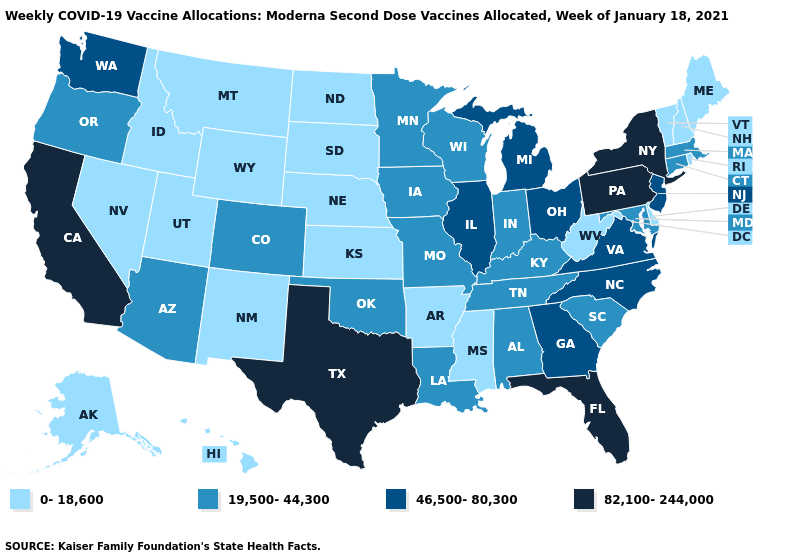What is the highest value in the MidWest ?
Write a very short answer. 46,500-80,300. Among the states that border Indiana , which have the highest value?
Quick response, please. Illinois, Michigan, Ohio. What is the value of Indiana?
Short answer required. 19,500-44,300. Which states have the lowest value in the South?
Give a very brief answer. Arkansas, Delaware, Mississippi, West Virginia. Does Colorado have the lowest value in the West?
Short answer required. No. Among the states that border Massachusetts , which have the lowest value?
Short answer required. New Hampshire, Rhode Island, Vermont. Which states have the lowest value in the USA?
Give a very brief answer. Alaska, Arkansas, Delaware, Hawaii, Idaho, Kansas, Maine, Mississippi, Montana, Nebraska, Nevada, New Hampshire, New Mexico, North Dakota, Rhode Island, South Dakota, Utah, Vermont, West Virginia, Wyoming. What is the lowest value in states that border Delaware?
Concise answer only. 19,500-44,300. What is the value of New York?
Concise answer only. 82,100-244,000. Name the states that have a value in the range 82,100-244,000?
Be succinct. California, Florida, New York, Pennsylvania, Texas. Name the states that have a value in the range 19,500-44,300?
Be succinct. Alabama, Arizona, Colorado, Connecticut, Indiana, Iowa, Kentucky, Louisiana, Maryland, Massachusetts, Minnesota, Missouri, Oklahoma, Oregon, South Carolina, Tennessee, Wisconsin. Does Rhode Island have a lower value than New Hampshire?
Answer briefly. No. Does the map have missing data?
Write a very short answer. No. What is the value of Alaska?
Give a very brief answer. 0-18,600. What is the highest value in the USA?
Give a very brief answer. 82,100-244,000. 